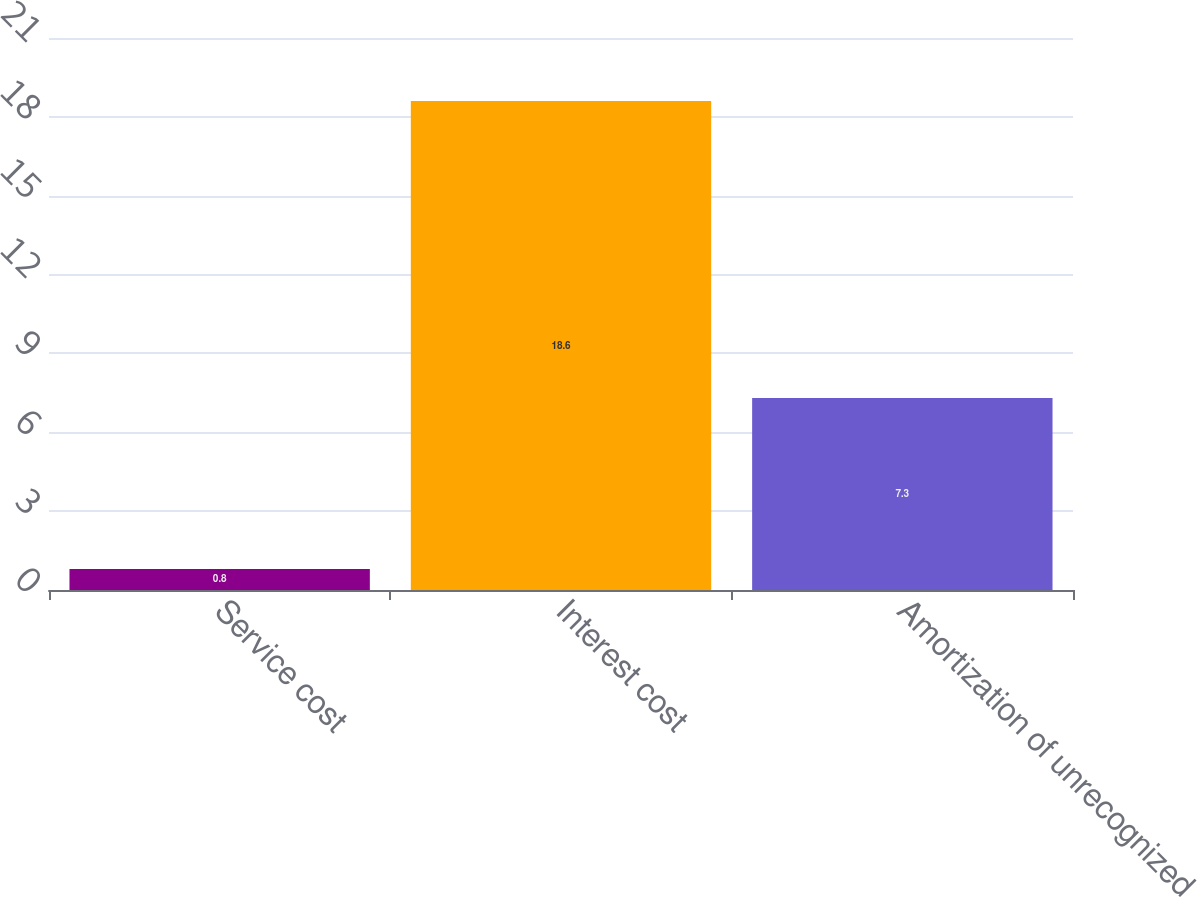Convert chart. <chart><loc_0><loc_0><loc_500><loc_500><bar_chart><fcel>Service cost<fcel>Interest cost<fcel>Amortization of unrecognized<nl><fcel>0.8<fcel>18.6<fcel>7.3<nl></chart> 